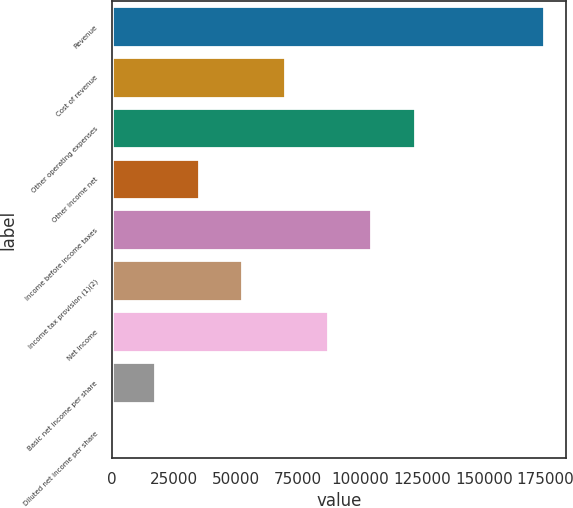Convert chart to OTSL. <chart><loc_0><loc_0><loc_500><loc_500><bar_chart><fcel>Revenue<fcel>Cost of revenue<fcel>Other operating expenses<fcel>Other income net<fcel>Income before income taxes<fcel>Income tax provision (1)(2)<fcel>Net income<fcel>Basic net income per share<fcel>Diluted net income per share<nl><fcel>174436<fcel>69774.9<fcel>122105<fcel>34887.8<fcel>104662<fcel>52331.4<fcel>87218.4<fcel>17444.3<fcel>0.8<nl></chart> 